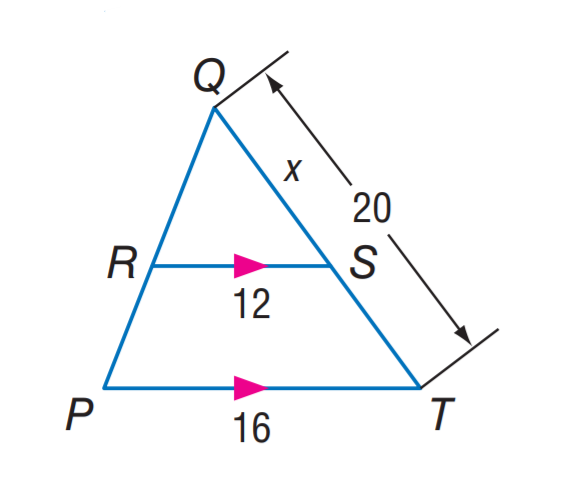Question: Find S T.
Choices:
A. 5
B. 10
C. 12
D. 16
Answer with the letter. Answer: A 